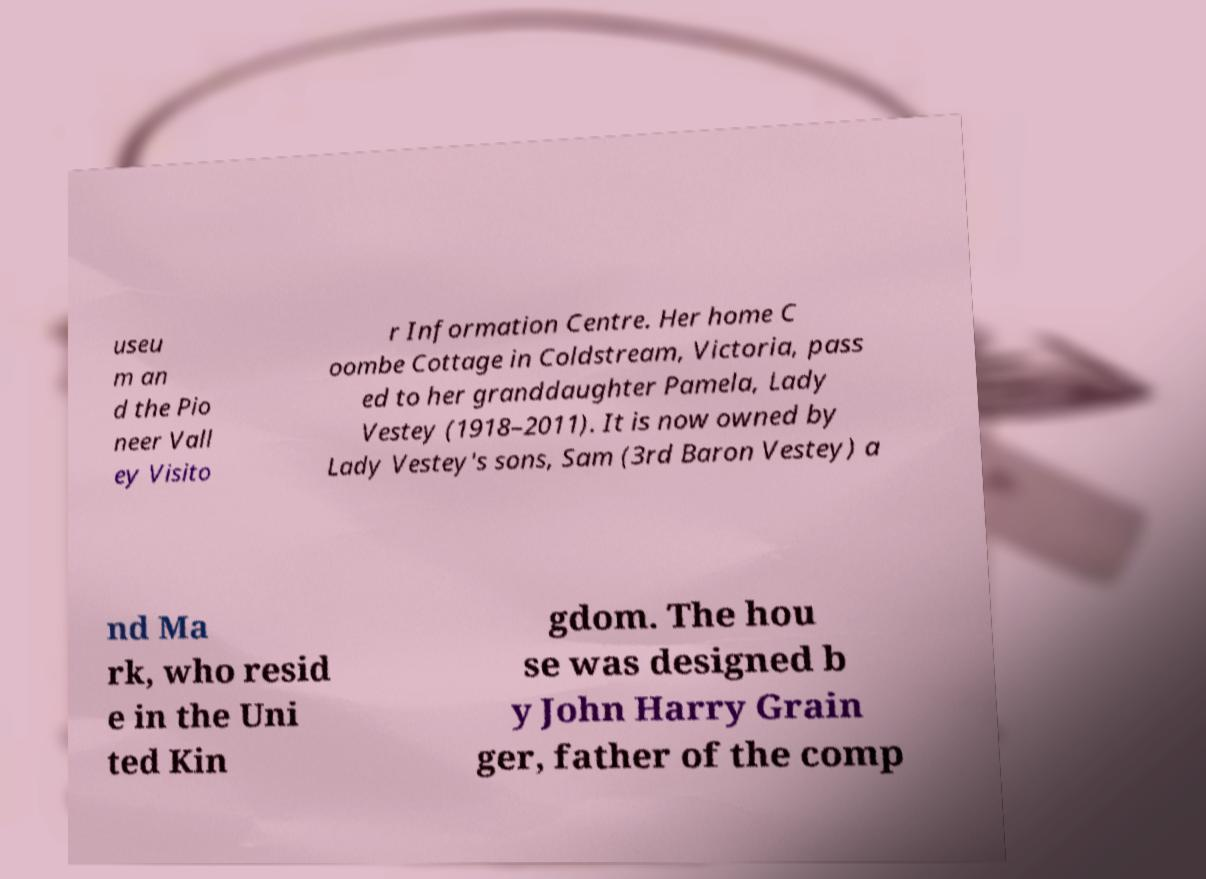What messages or text are displayed in this image? I need them in a readable, typed format. useu m an d the Pio neer Vall ey Visito r Information Centre. Her home C oombe Cottage in Coldstream, Victoria, pass ed to her granddaughter Pamela, Lady Vestey (1918–2011). It is now owned by Lady Vestey's sons, Sam (3rd Baron Vestey) a nd Ma rk, who resid e in the Uni ted Kin gdom. The hou se was designed b y John Harry Grain ger, father of the comp 